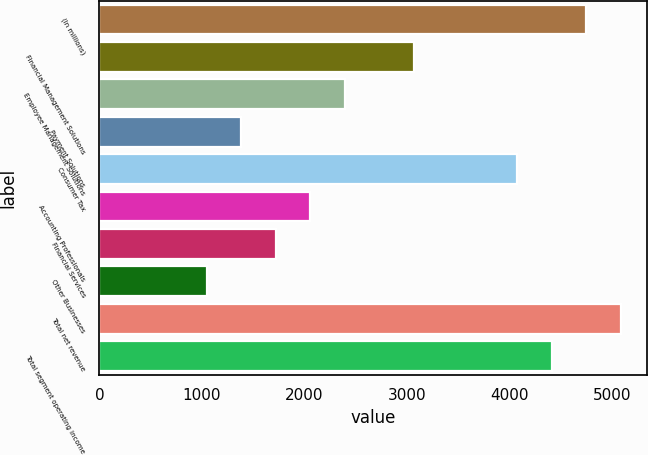<chart> <loc_0><loc_0><loc_500><loc_500><bar_chart><fcel>(In millions)<fcel>Financial Management Solutions<fcel>Employee Management Solutions<fcel>Payment Solutions<fcel>Consumer Tax<fcel>Accounting Professionals<fcel>Financial Services<fcel>Other Businesses<fcel>Total net revenue<fcel>Total segment operating income<nl><fcel>4747.4<fcel>3066.9<fcel>2394.7<fcel>1386.4<fcel>4075.2<fcel>2058.6<fcel>1722.5<fcel>1050.3<fcel>5083.5<fcel>4411.3<nl></chart> 